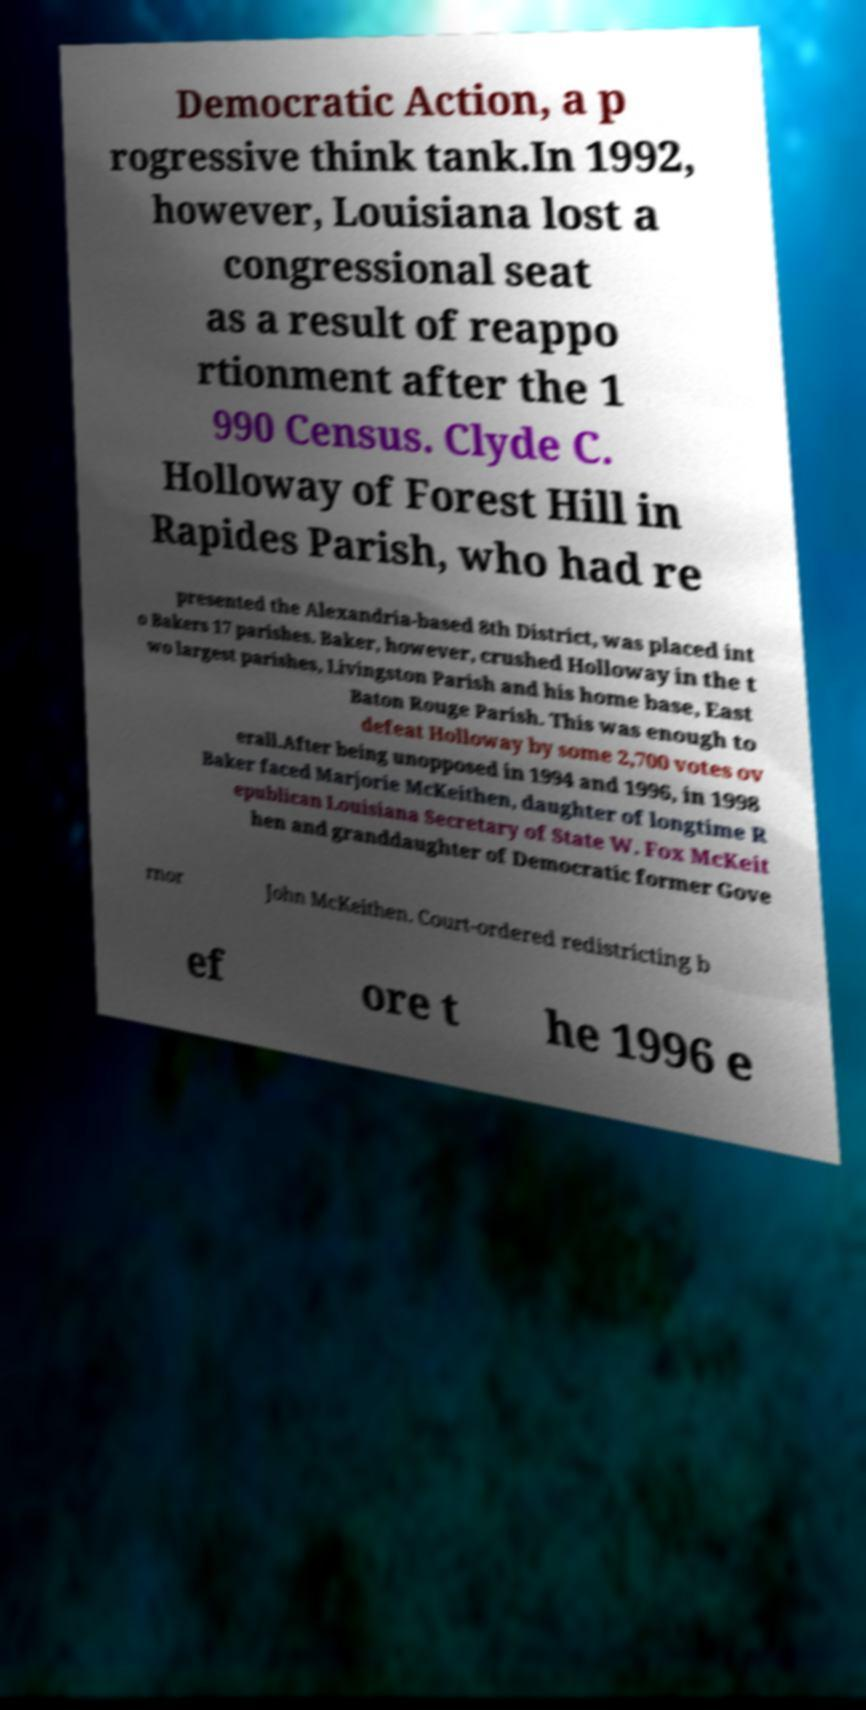For documentation purposes, I need the text within this image transcribed. Could you provide that? Democratic Action, a p rogressive think tank.In 1992, however, Louisiana lost a congressional seat as a result of reappo rtionment after the 1 990 Census. Clyde C. Holloway of Forest Hill in Rapides Parish, who had re presented the Alexandria-based 8th District, was placed int o Bakers 17 parishes. Baker, however, crushed Holloway in the t wo largest parishes, Livingston Parish and his home base, East Baton Rouge Parish. This was enough to defeat Holloway by some 2,700 votes ov erall.After being unopposed in 1994 and 1996, in 1998 Baker faced Marjorie McKeithen, daughter of longtime R epublican Louisiana Secretary of State W. Fox McKeit hen and granddaughter of Democratic former Gove rnor John McKeithen. Court-ordered redistricting b ef ore t he 1996 e 